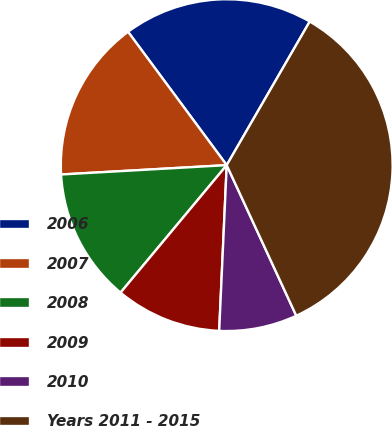<chart> <loc_0><loc_0><loc_500><loc_500><pie_chart><fcel>2006<fcel>2007<fcel>2008<fcel>2009<fcel>2010<fcel>Years 2011 - 2015<nl><fcel>18.48%<fcel>15.76%<fcel>13.05%<fcel>10.33%<fcel>7.61%<fcel>34.77%<nl></chart> 